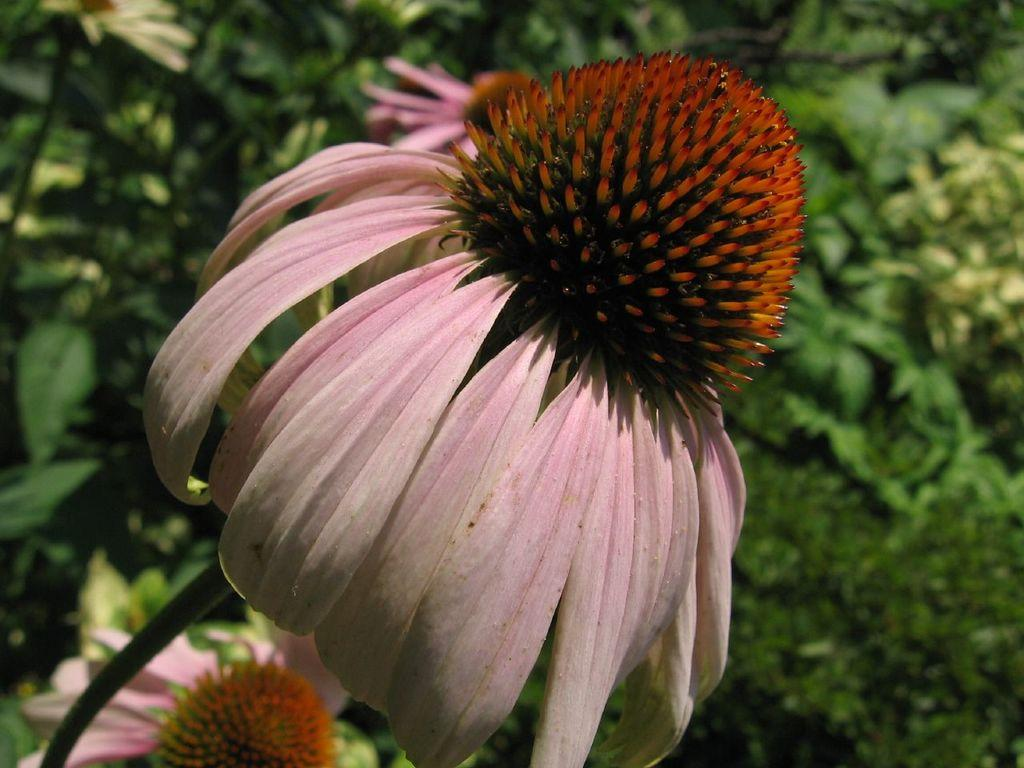What is the main subject of the image? There is a flower in the image. Are there any other plants visible in the image? Yes, there are plants behind the flower in the image. How many toes can be seen on the flower in the image? There are no toes visible in the image, as it features a flower and plants. 